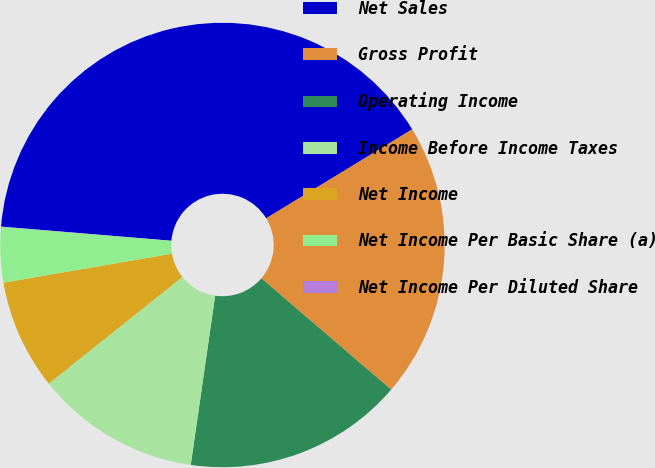Convert chart. <chart><loc_0><loc_0><loc_500><loc_500><pie_chart><fcel>Net Sales<fcel>Gross Profit<fcel>Operating Income<fcel>Income Before Income Taxes<fcel>Net Income<fcel>Net Income Per Basic Share (a)<fcel>Net Income Per Diluted Share<nl><fcel>39.97%<fcel>19.99%<fcel>16.0%<fcel>12.0%<fcel>8.01%<fcel>4.01%<fcel>0.02%<nl></chart> 